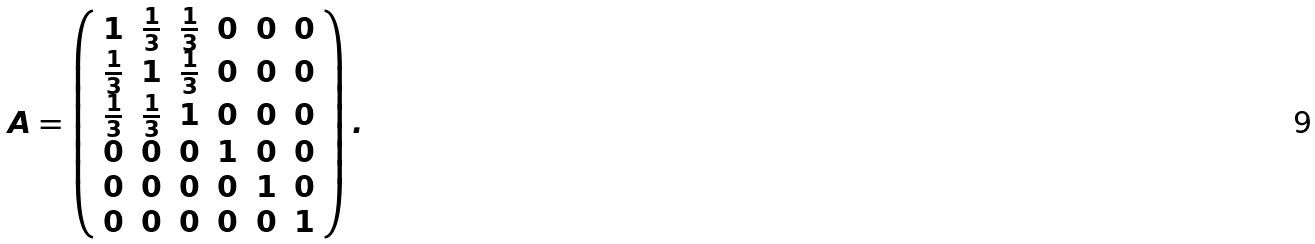Convert formula to latex. <formula><loc_0><loc_0><loc_500><loc_500>A = \left ( \begin{array} { c c c c c c } 1 & \frac { 1 } { 3 } & \frac { 1 } { 3 } & 0 & 0 & 0 \\ \frac { 1 } { 3 } & 1 & \frac { 1 } { 3 } & 0 & 0 & 0 \\ \frac { 1 } { 3 } & \frac { 1 } { 3 } & 1 & 0 & 0 & 0 \\ 0 & 0 & 0 & 1 & 0 & 0 \\ 0 & 0 & 0 & 0 & 1 & 0 \\ 0 & 0 & 0 & 0 & 0 & 1 \end{array} \right ) .</formula> 